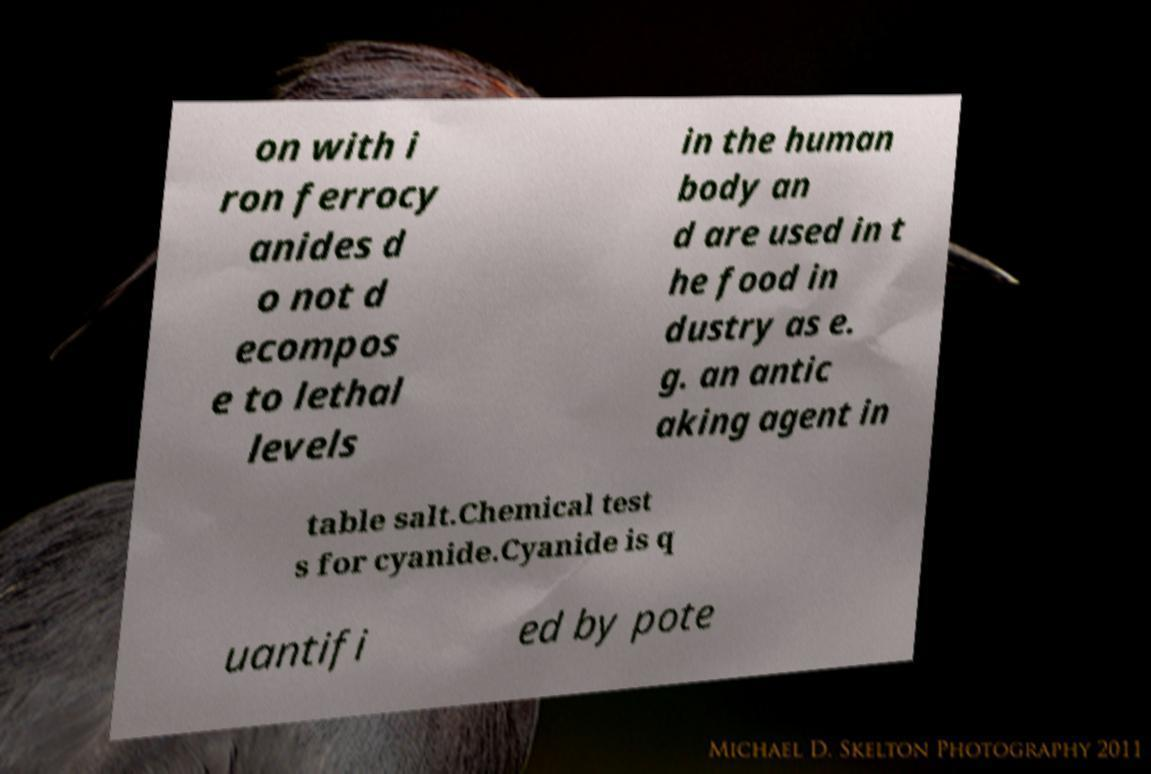I need the written content from this picture converted into text. Can you do that? on with i ron ferrocy anides d o not d ecompos e to lethal levels in the human body an d are used in t he food in dustry as e. g. an antic aking agent in table salt.Chemical test s for cyanide.Cyanide is q uantifi ed by pote 